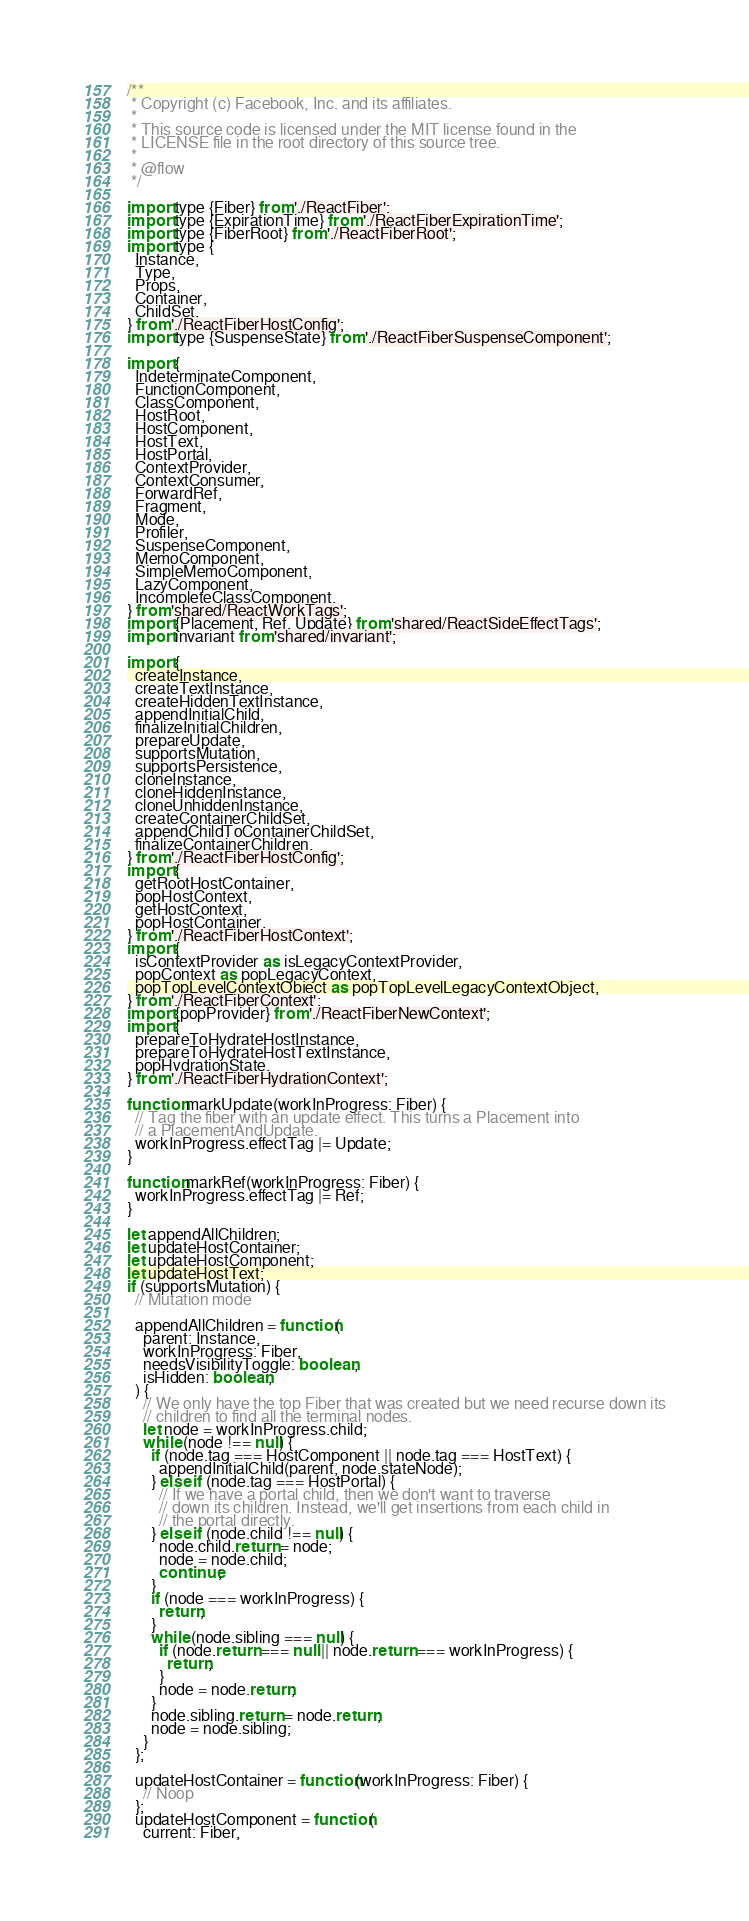<code> <loc_0><loc_0><loc_500><loc_500><_JavaScript_>/**
 * Copyright (c) Facebook, Inc. and its affiliates.
 *
 * This source code is licensed under the MIT license found in the
 * LICENSE file in the root directory of this source tree.
 *
 * @flow
 */

import type {Fiber} from './ReactFiber';
import type {ExpirationTime} from './ReactFiberExpirationTime';
import type {FiberRoot} from './ReactFiberRoot';
import type {
  Instance,
  Type,
  Props,
  Container,
  ChildSet,
} from './ReactFiberHostConfig';
import type {SuspenseState} from './ReactFiberSuspenseComponent';

import {
  IndeterminateComponent,
  FunctionComponent,
  ClassComponent,
  HostRoot,
  HostComponent,
  HostText,
  HostPortal,
  ContextProvider,
  ContextConsumer,
  ForwardRef,
  Fragment,
  Mode,
  Profiler,
  SuspenseComponent,
  MemoComponent,
  SimpleMemoComponent,
  LazyComponent,
  IncompleteClassComponent,
} from 'shared/ReactWorkTags';
import {Placement, Ref, Update} from 'shared/ReactSideEffectTags';
import invariant from 'shared/invariant';

import {
  createInstance,
  createTextInstance,
  createHiddenTextInstance,
  appendInitialChild,
  finalizeInitialChildren,
  prepareUpdate,
  supportsMutation,
  supportsPersistence,
  cloneInstance,
  cloneHiddenInstance,
  cloneUnhiddenInstance,
  createContainerChildSet,
  appendChildToContainerChildSet,
  finalizeContainerChildren,
} from './ReactFiberHostConfig';
import {
  getRootHostContainer,
  popHostContext,
  getHostContext,
  popHostContainer,
} from './ReactFiberHostContext';
import {
  isContextProvider as isLegacyContextProvider,
  popContext as popLegacyContext,
  popTopLevelContextObject as popTopLevelLegacyContextObject,
} from './ReactFiberContext';
import {popProvider} from './ReactFiberNewContext';
import {
  prepareToHydrateHostInstance,
  prepareToHydrateHostTextInstance,
  popHydrationState,
} from './ReactFiberHydrationContext';

function markUpdate(workInProgress: Fiber) {
  // Tag the fiber with an update effect. This turns a Placement into
  // a PlacementAndUpdate.
  workInProgress.effectTag |= Update;
}

function markRef(workInProgress: Fiber) {
  workInProgress.effectTag |= Ref;
}

let appendAllChildren;
let updateHostContainer;
let updateHostComponent;
let updateHostText;
if (supportsMutation) {
  // Mutation mode

  appendAllChildren = function(
    parent: Instance,
    workInProgress: Fiber,
    needsVisibilityToggle: boolean,
    isHidden: boolean,
  ) {
    // We only have the top Fiber that was created but we need recurse down its
    // children to find all the terminal nodes.
    let node = workInProgress.child;
    while (node !== null) {
      if (node.tag === HostComponent || node.tag === HostText) {
        appendInitialChild(parent, node.stateNode);
      } else if (node.tag === HostPortal) {
        // If we have a portal child, then we don't want to traverse
        // down its children. Instead, we'll get insertions from each child in
        // the portal directly.
      } else if (node.child !== null) {
        node.child.return = node;
        node = node.child;
        continue;
      }
      if (node === workInProgress) {
        return;
      }
      while (node.sibling === null) {
        if (node.return === null || node.return === workInProgress) {
          return;
        }
        node = node.return;
      }
      node.sibling.return = node.return;
      node = node.sibling;
    }
  };

  updateHostContainer = function(workInProgress: Fiber) {
    // Noop
  };
  updateHostComponent = function(
    current: Fiber,</code> 